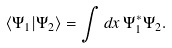<formula> <loc_0><loc_0><loc_500><loc_500>\langle \Psi _ { 1 } | \Psi _ { 2 } \rangle = \int d x \, \Psi _ { 1 } ^ { \ast } \Psi _ { 2 } .</formula> 